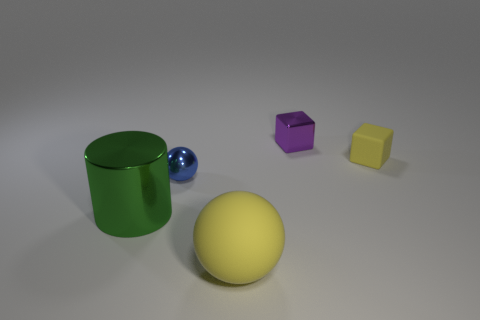Add 3 small red cylinders. How many objects exist? 8 Subtract all cylinders. How many objects are left? 4 Add 1 big purple metal balls. How many big purple metal balls exist? 1 Subtract 1 purple blocks. How many objects are left? 4 Subtract all tiny yellow rubber objects. Subtract all small purple things. How many objects are left? 3 Add 3 purple metallic objects. How many purple metallic objects are left? 4 